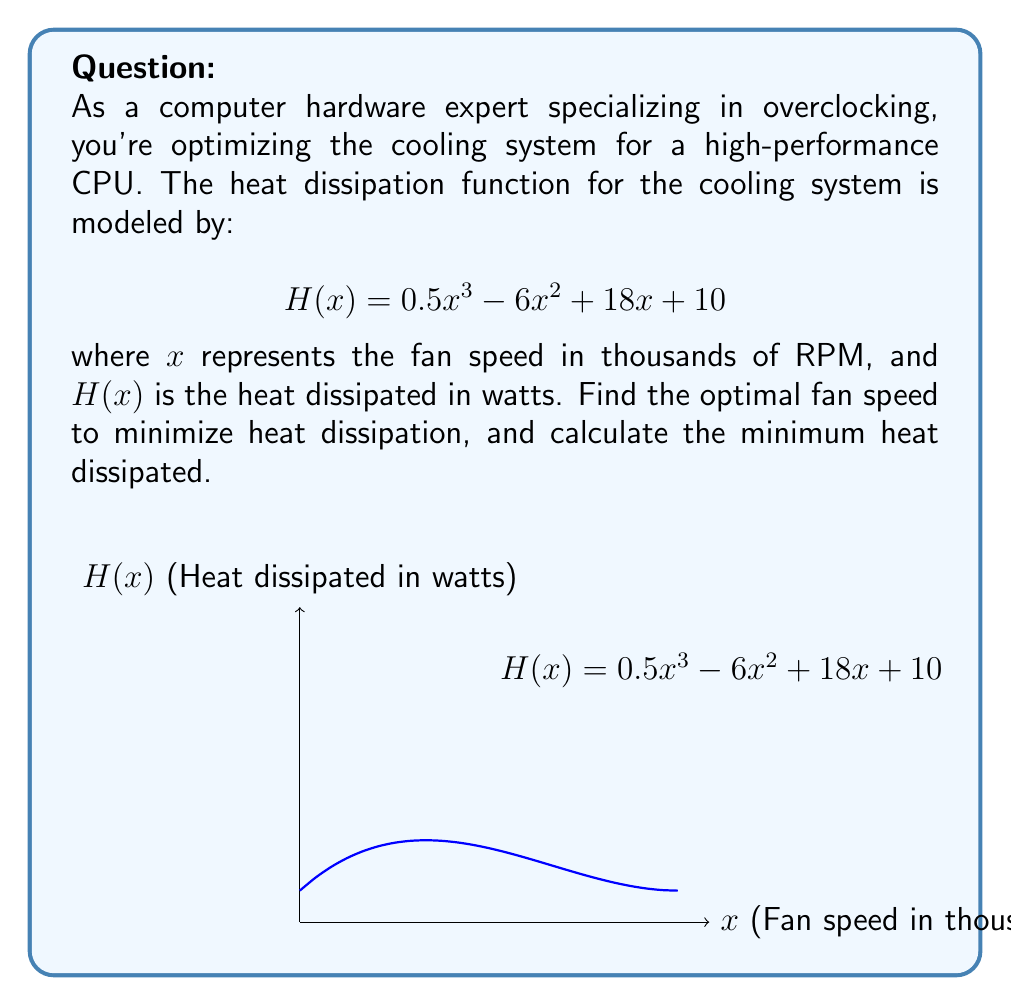Help me with this question. To find the optimal fan speed that minimizes heat dissipation, we need to find the minimum of the function $H(x)$. This can be done by following these steps:

1) First, we find the derivative of $H(x)$:
   $$H'(x) = 1.5x^2 - 12x + 18$$

2) To find the critical points, we set $H'(x) = 0$ and solve:
   $$1.5x^2 - 12x + 18 = 0$$
   $$1.5(x^2 - 8x + 12) = 0$$
   $$1.5(x - 6)(x - 2) = 0$$
   
   So, $x = 6$ or $x = 2$

3) We check the second derivative to determine which critical point is a minimum:
   $$H''(x) = 3x - 12$$
   
   At $x = 2$: $H''(2) = 3(2) - 12 = -6 < 0$, so this is a local maximum.
   At $x = 6$: $H''(6) = 3(6) - 12 = 6 > 0$, so this is a local minimum.

4) Therefore, the optimal fan speed is 6 thousand RPM.

5) To find the minimum heat dissipated, we evaluate $H(6)$:
   $$H(6) = 0.5(6^3) - 6(6^2) + 18(6) + 10$$
   $$= 108 - 216 + 108 + 10 = 10\text{ watts}$$

Thus, the minimum heat dissipated is 10 watts at a fan speed of 6 thousand RPM.
Answer: Optimal fan speed: 6 thousand RPM; Minimum heat dissipated: 10 watts 